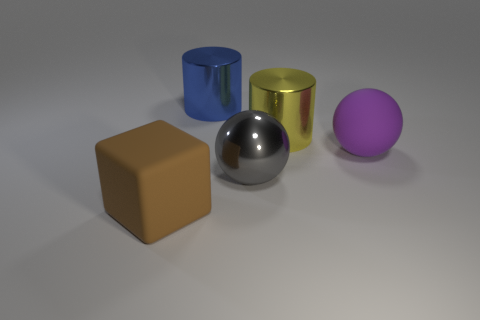What number of other things are there of the same shape as the brown object?
Your answer should be compact. 0. What number of other objects are the same size as the yellow metal cylinder?
Give a very brief answer. 4. How many objects are both left of the big gray thing and behind the large brown cube?
Make the answer very short. 1. There is a rubber thing to the right of the block; is its size the same as the shiny thing in front of the purple matte ball?
Offer a very short reply. Yes. What size is the rubber thing that is left of the big yellow cylinder?
Your answer should be compact. Large. How many things are large matte things that are behind the brown cube or metal cylinders left of the big yellow cylinder?
Keep it short and to the point. 2. Are there any other things that have the same color as the big block?
Ensure brevity in your answer.  No. Is the number of yellow metal cylinders that are behind the blue metallic thing the same as the number of purple spheres behind the large yellow metal cylinder?
Ensure brevity in your answer.  Yes. Is the number of big purple matte spheres behind the big purple rubber object greater than the number of big brown objects?
Ensure brevity in your answer.  No. What number of things are either objects in front of the large yellow metallic cylinder or large things?
Provide a succinct answer. 5. 